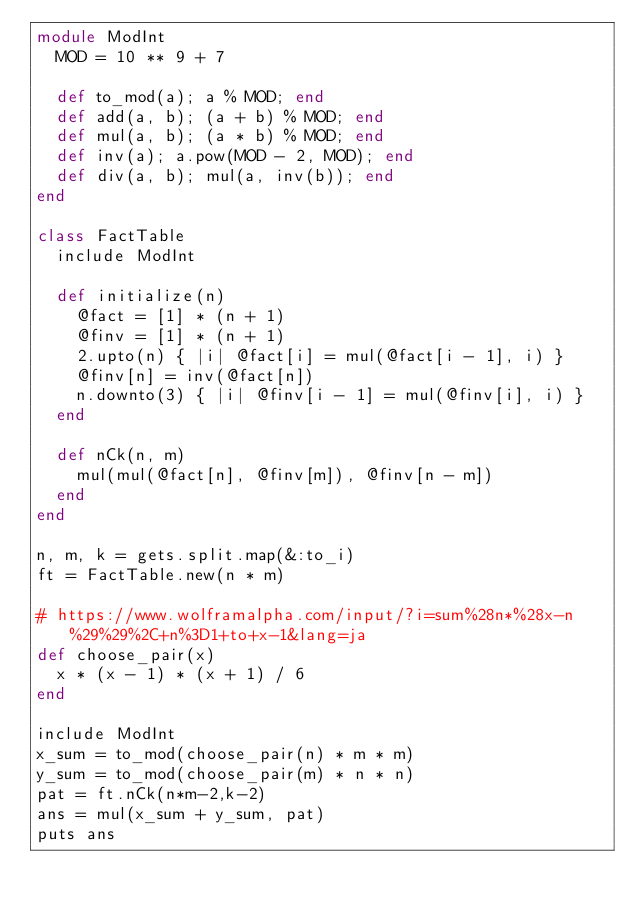Convert code to text. <code><loc_0><loc_0><loc_500><loc_500><_Ruby_>module ModInt
  MOD = 10 ** 9 + 7

  def to_mod(a); a % MOD; end
  def add(a, b); (a + b) % MOD; end
  def mul(a, b); (a * b) % MOD; end
  def inv(a); a.pow(MOD - 2, MOD); end
  def div(a, b); mul(a, inv(b)); end
end

class FactTable
  include ModInt

  def initialize(n)
    @fact = [1] * (n + 1)
    @finv = [1] * (n + 1)
    2.upto(n) { |i| @fact[i] = mul(@fact[i - 1], i) }
    @finv[n] = inv(@fact[n])
    n.downto(3) { |i| @finv[i - 1] = mul(@finv[i], i) }
  end

  def nCk(n, m)
    mul(mul(@fact[n], @finv[m]), @finv[n - m])
  end
end

n, m, k = gets.split.map(&:to_i)
ft = FactTable.new(n * m)

# https://www.wolframalpha.com/input/?i=sum%28n*%28x-n%29%29%2C+n%3D1+to+x-1&lang=ja
def choose_pair(x)
  x * (x - 1) * (x + 1) / 6
end

include ModInt
x_sum = to_mod(choose_pair(n) * m * m)
y_sum = to_mod(choose_pair(m) * n * n)
pat = ft.nCk(n*m-2,k-2)
ans = mul(x_sum + y_sum, pat)
puts ans
</code> 